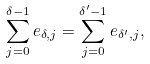<formula> <loc_0><loc_0><loc_500><loc_500>\sum _ { j = 0 } ^ { \delta - 1 } e _ { \delta , j } = \sum _ { j = 0 } ^ { \delta ^ { \prime } - 1 } e _ { \delta ^ { \prime } , j } ,</formula> 